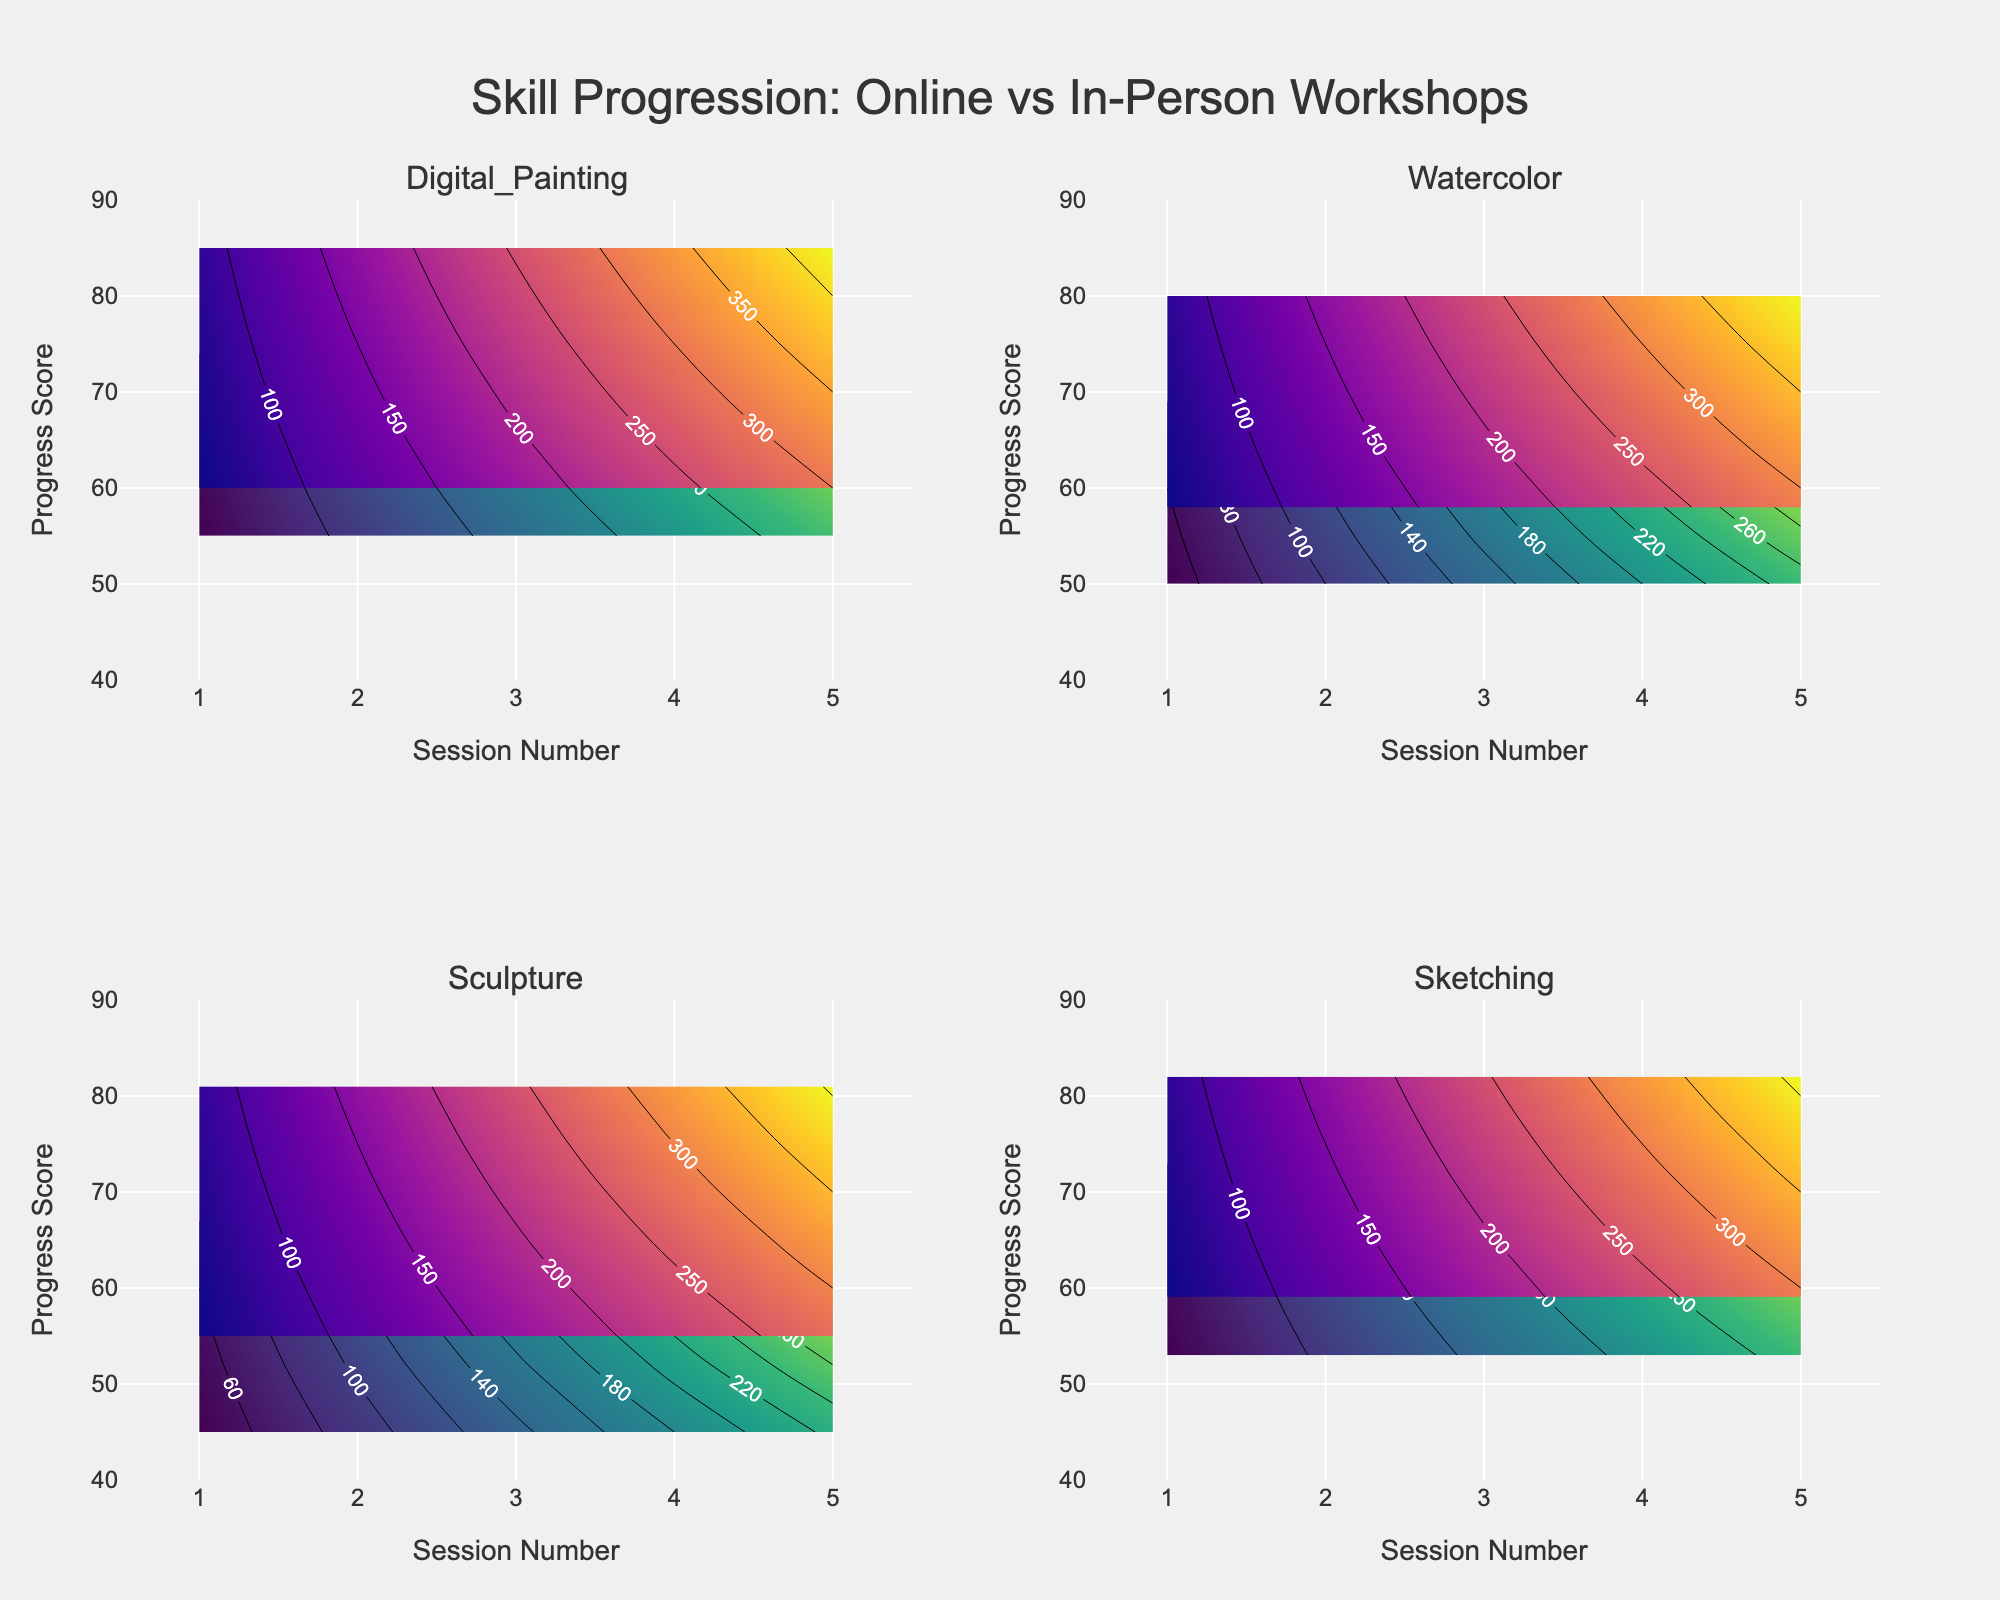Which workshop type shows a higher initial progress score for Digital Painting? The figure shows the contours for both Online and In-Person sessions for Digital Painting. By observing the starting points on the progress score axis (initial values), the In-Person workshop begins at a higher score than the Online workshop.
Answer: In-Person What is the title of the figure? The title is typically displayed at the top center of the figure and provides an overall description of the plotted data.
Answer: Skill Progression: Online vs In-Person Workshops How does the progress score for Online workshops in Watercolor change from Session 1 to Session 5? Checking the progress score values along the y-axis for each session from 1 to 5 in the Watercolor subplot for Online workshops will show how the scores increase.
Answer: It increases from 50 to 69 Which technique has the smallest difference in progress between Online and In-Person workshops by Session 5? By comparing the values for both Online and In-Person from each technique's contours at Session 5, we observe the differences.
Answer: Sculpture For in-person Digital Painting, what is the highest progress score achieved, and in which session does it occur? Observing the highest point on the y-axis within the Digital Painting subplot for In-Person workshops, the session number is shown on the x-axis corresponding to the highest point.
Answer: 85 in Session 5 Which techniques use the color scales 'Viridis' and 'Plasma,' respectively? The color scale legends or the figure itself can indicate the color scales used for Online and In-Person workshops. 'Viridis' is for Online workshops and 'Plasma' for In-Person workshops.
Answer: All techniques use 'Viridis' for Online and 'Plasma' for In-Person How does the progress trend for in-person Sketching compare to online Sketching? By visually comparing how the contours progress from Session 1 to Session 5 in both scenarios within the Sketching subplot, the trend can be observed.
Answer: In-person Sketching shows a steeper increase in progress scores than online Sketching Which session has the largest progress gap between Online and In-Person sessions for Watercolor? By observing each session’s progress scores for both Online and In-Person in the Watercolor subplot, we identify where the difference in progress scores is the largest.
Answer: Session 5 In which session does Online Sculpture achieve a progress score close to 60? By tracing the contours for Online Sculpture to find where the y-axis value (Progress Score) is closest to 60 and checking the corresponding session number on the x-axis.
Answer: Session 3 